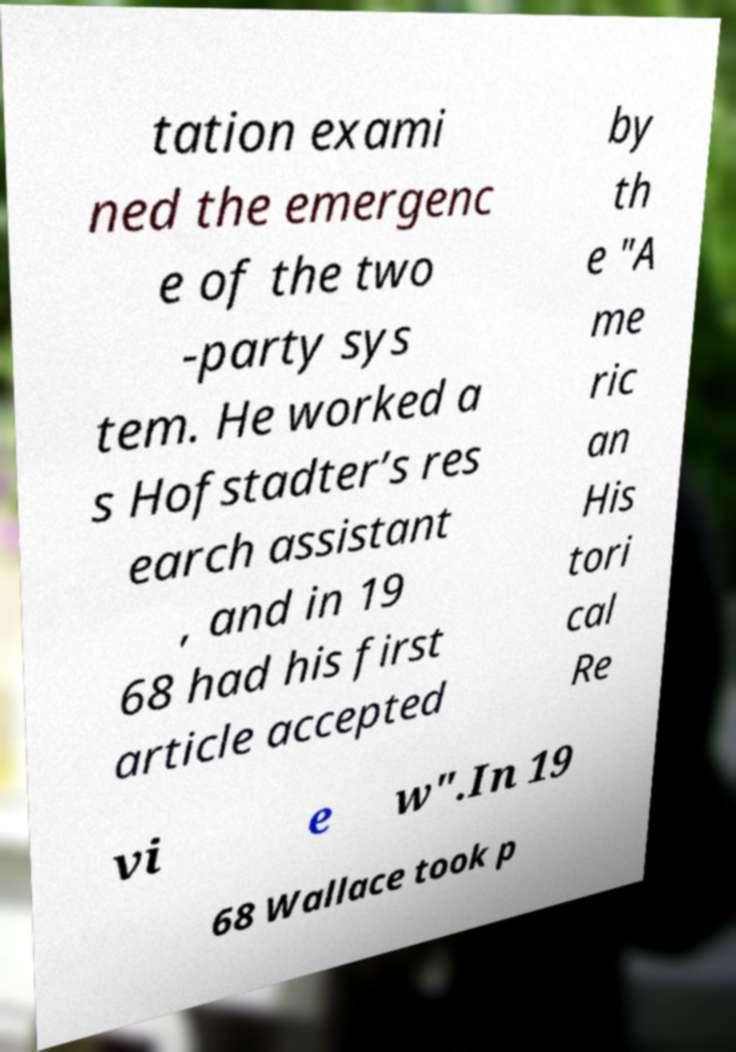Can you accurately transcribe the text from the provided image for me? tation exami ned the emergenc e of the two -party sys tem. He worked a s Hofstadter’s res earch assistant , and in 19 68 had his first article accepted by th e "A me ric an His tori cal Re vi e w".In 19 68 Wallace took p 